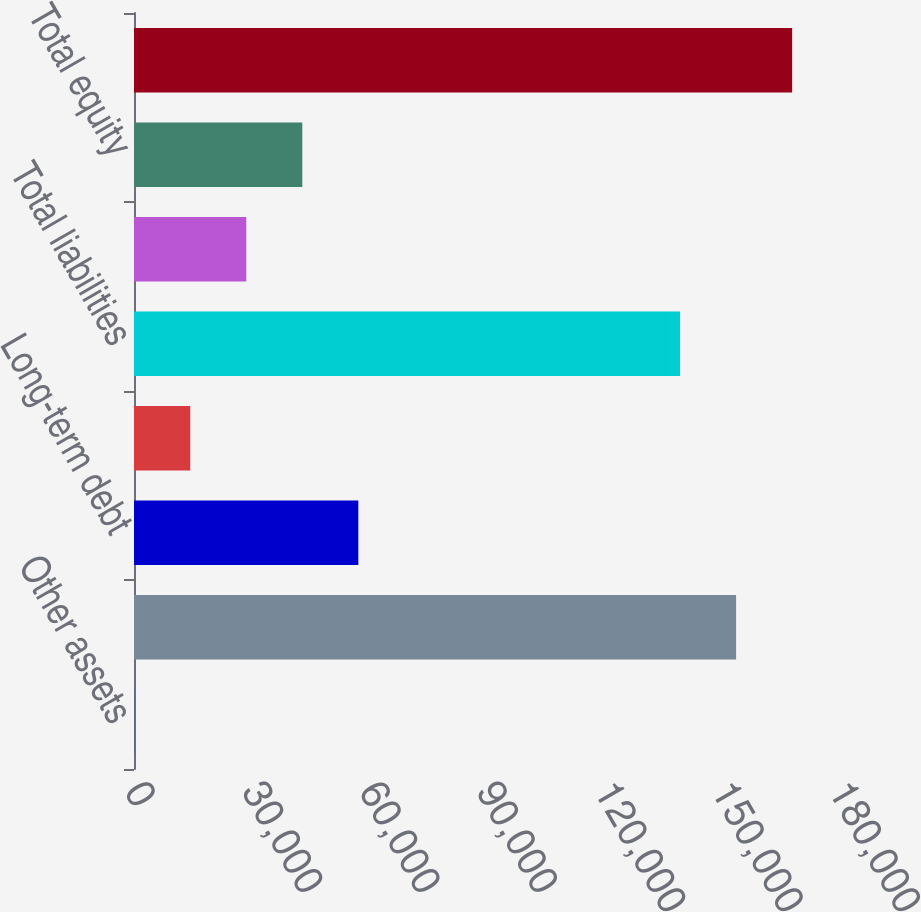<chart> <loc_0><loc_0><loc_500><loc_500><bar_chart><fcel>Other assets<fcel>Total assets<fcel>Long-term debt<fcel>Other liabilities<fcel>Total liabilities<fcel>Citigroup stockholders' equity<fcel>Total equity<fcel>Total liabilities and<nl><fcel>51<fcel>153949<fcel>57358.6<fcel>14377.9<fcel>139622<fcel>28704.8<fcel>43031.7<fcel>168276<nl></chart> 